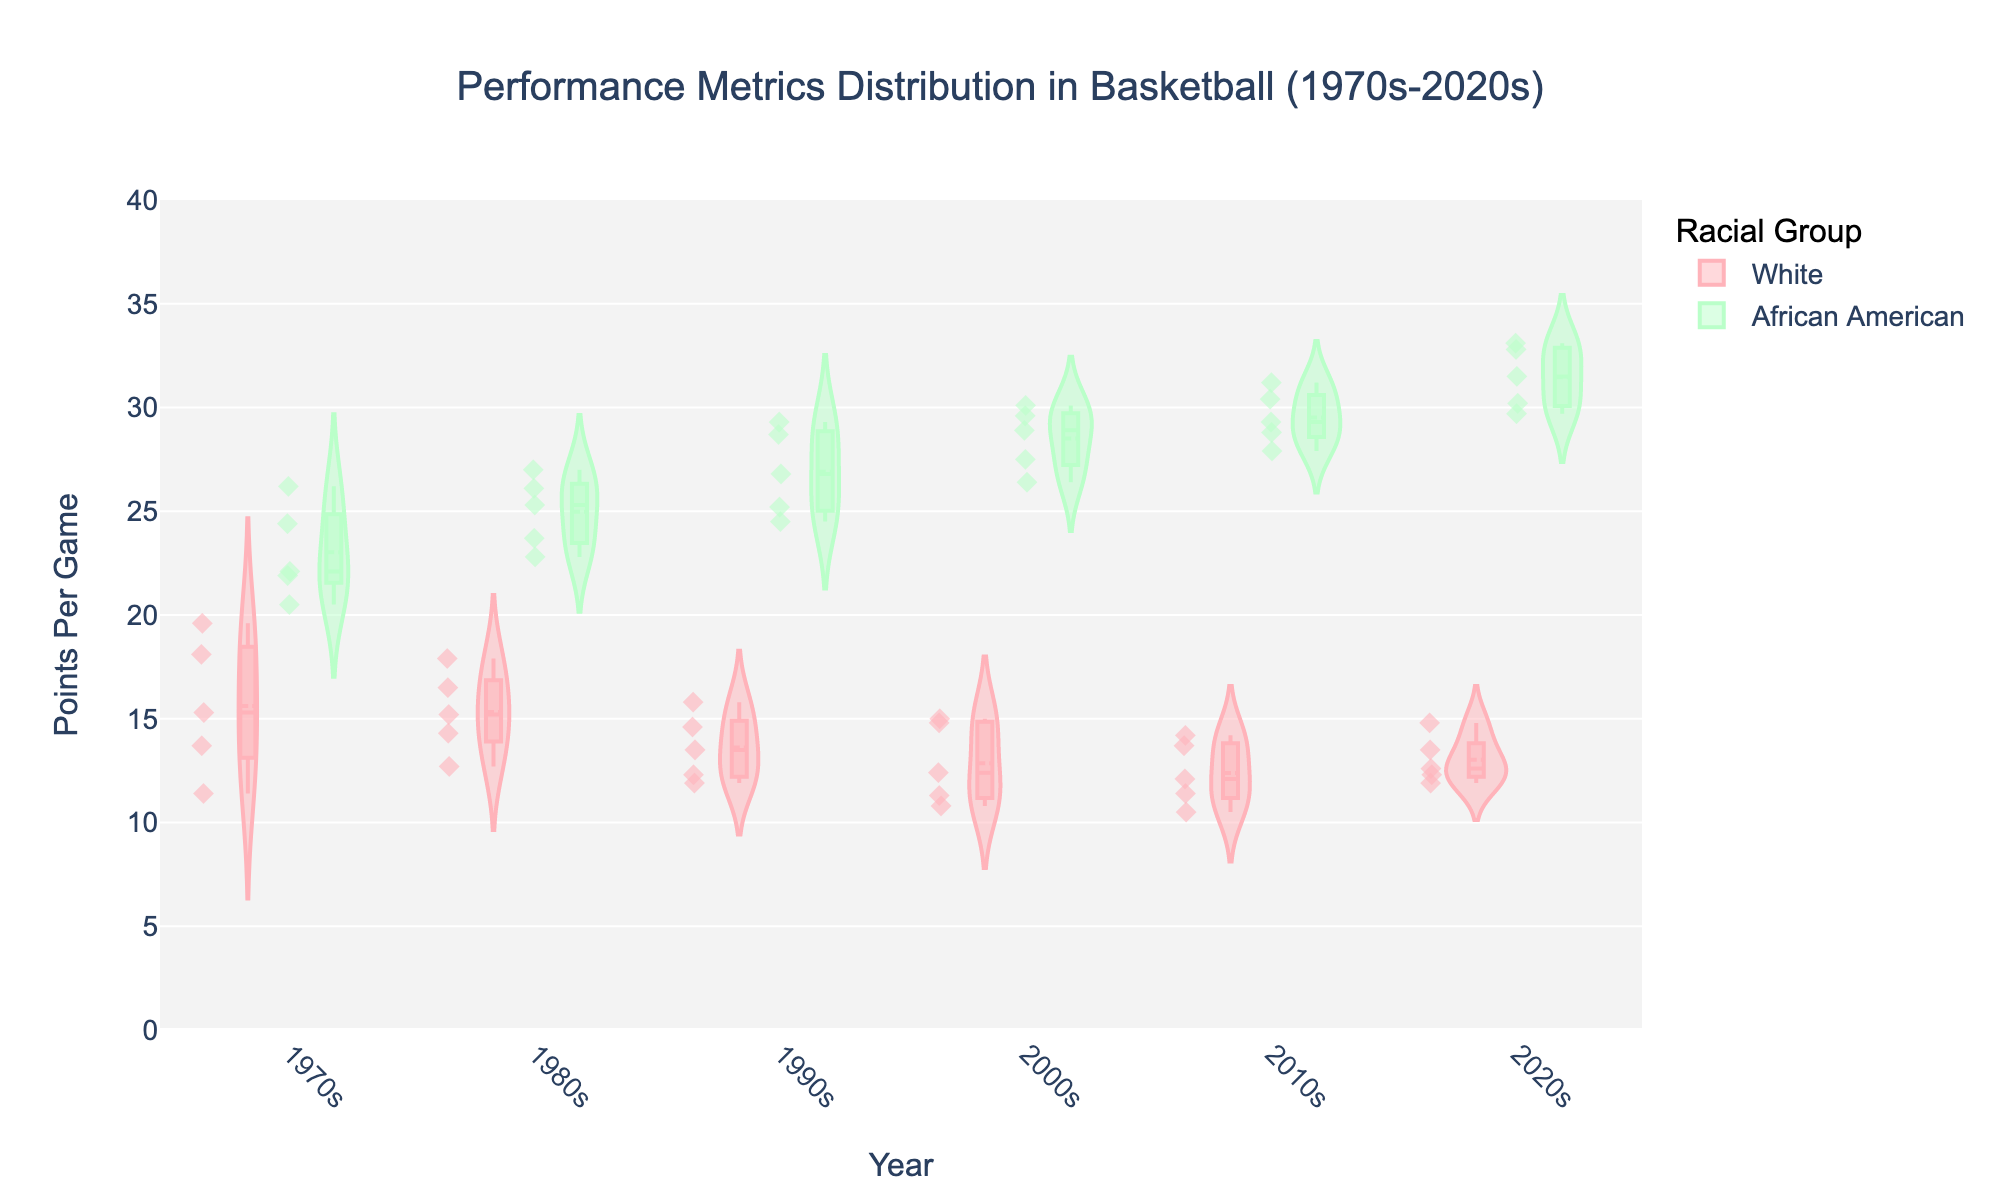What is the title of the figure? The title can be found at the top of the figure. The title of this figure is "Performance Metrics Distribution in Basketball (1970s-2020s)."
Answer: Performance Metrics Distribution in Basketball (1970s-2020s) How are the racial groups represented in the figure and what colors do they use? The racial groups are represented using different colors in the legend and violin plots. "White" is represented by a light pink color, and "African American" is represented by a light green color.
Answer: White: light pink, African American: light green What is the range of the y-axis in the figure? The y-axis range can be observed on the left side of the figure, and it spans from 0 to 40 points per game.
Answer: 0 to 40 During which decade did "African American" players have the highest median points per game according to the violin plot? The median points per game is indicated by the horizontal line within each violin in the box plot section. For "African American" players, the 2020s show the highest median, as the line is highest in that decade.
Answer: 2020s In which decade do "White" players have the most spread in their points per game based on the width of the violin plot? The width of the violin plot represents the distribution spread. The 1970s show the widest violin plot for "White" players, indicating the most spread.
Answer: 1970s Which racial group consistently scores higher points per game over the decades from 1970s to 2020s? By comparing the median lines in each violin plot across the decades, "African American" players consistently have higher points per game in each decade from 1970s to 2020s.
Answer: African American What is the median points per game for "White" players in the 2010s? Locate the box within the violin plot for "White" players in the 2010s. The median is marked by the line within the box. The median is roughly around 12 points per game.
Answer: 12 How does the distribution of points per game for "African American" players in the 1980s compare to "White" players in the same decade? Compare the width and median lines of the violin plots for both racial groups in the 1980s. "African American" players have higher median points per game and a wider distribution compared to "White" players.
Answer: Higher median and wider distribution Which decade shows the smallest difference in the median points per game between the two racial groups? To find this, compare the median lines within each decade's violin plots for both racial groups. The smallest difference appears in the 1970s, where the median points per game for both groups are closer than in other decades.
Answer: 1970s 